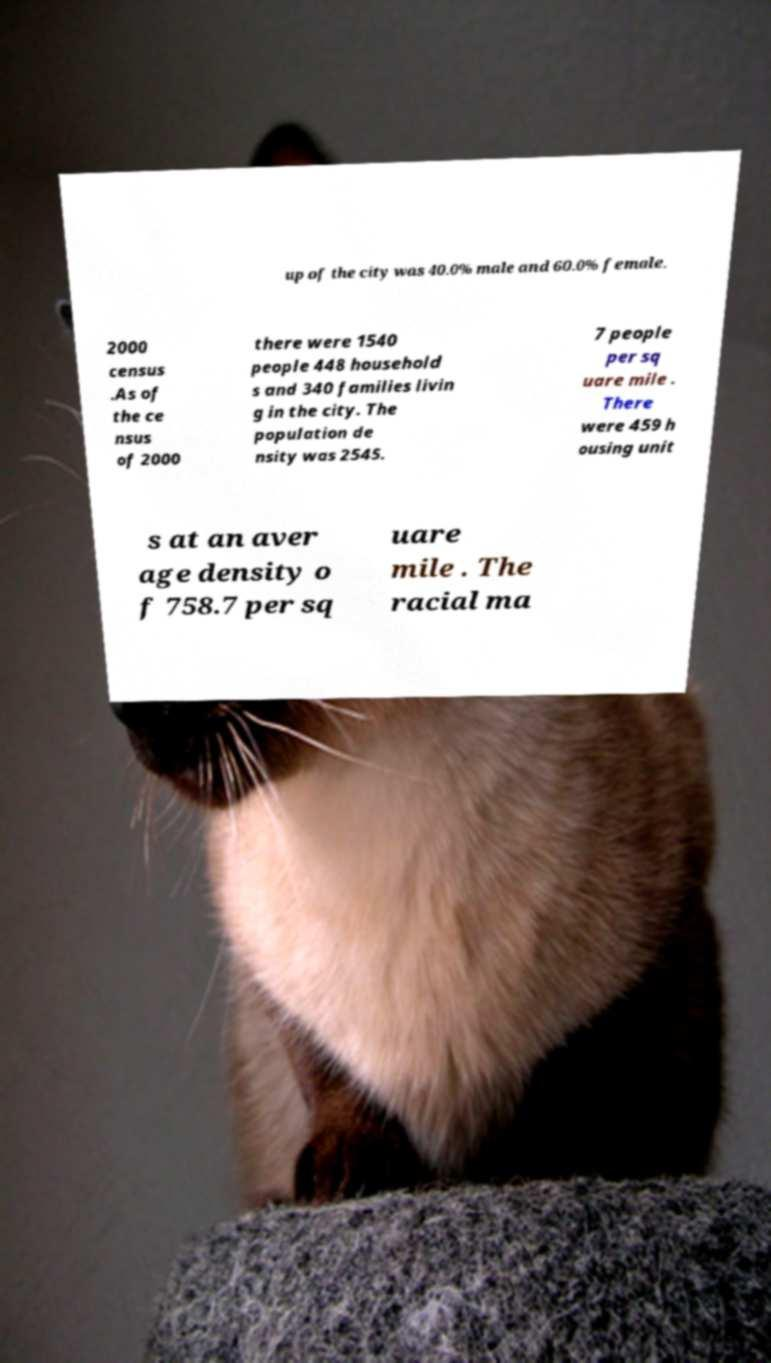Can you read and provide the text displayed in the image?This photo seems to have some interesting text. Can you extract and type it out for me? up of the city was 40.0% male and 60.0% female. 2000 census .As of the ce nsus of 2000 there were 1540 people 448 household s and 340 families livin g in the city. The population de nsity was 2545. 7 people per sq uare mile . There were 459 h ousing unit s at an aver age density o f 758.7 per sq uare mile . The racial ma 